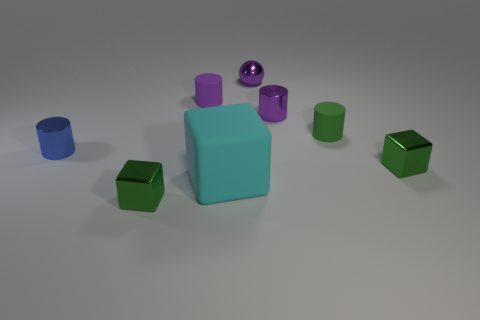What materials do the objects in the image look like they're made of? The objects in the image appear to be made of a matte plastic material, with a somewhat soft light diffusely reflecting off their surfaces. 